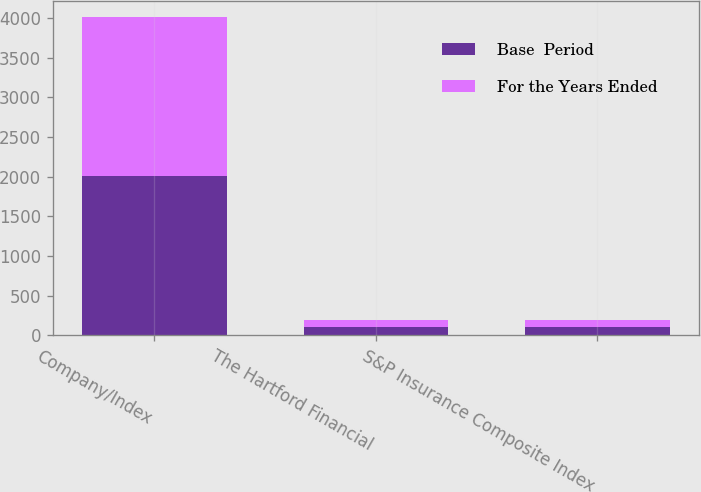Convert chart to OTSL. <chart><loc_0><loc_0><loc_500><loc_500><stacked_bar_chart><ecel><fcel>Company/Index<fcel>The Hartford Financial<fcel>S&P Insurance Composite Index<nl><fcel>Base  Period<fcel>2006<fcel>100<fcel>100<nl><fcel>For the Years Ended<fcel>2007<fcel>95.45<fcel>93.69<nl></chart> 